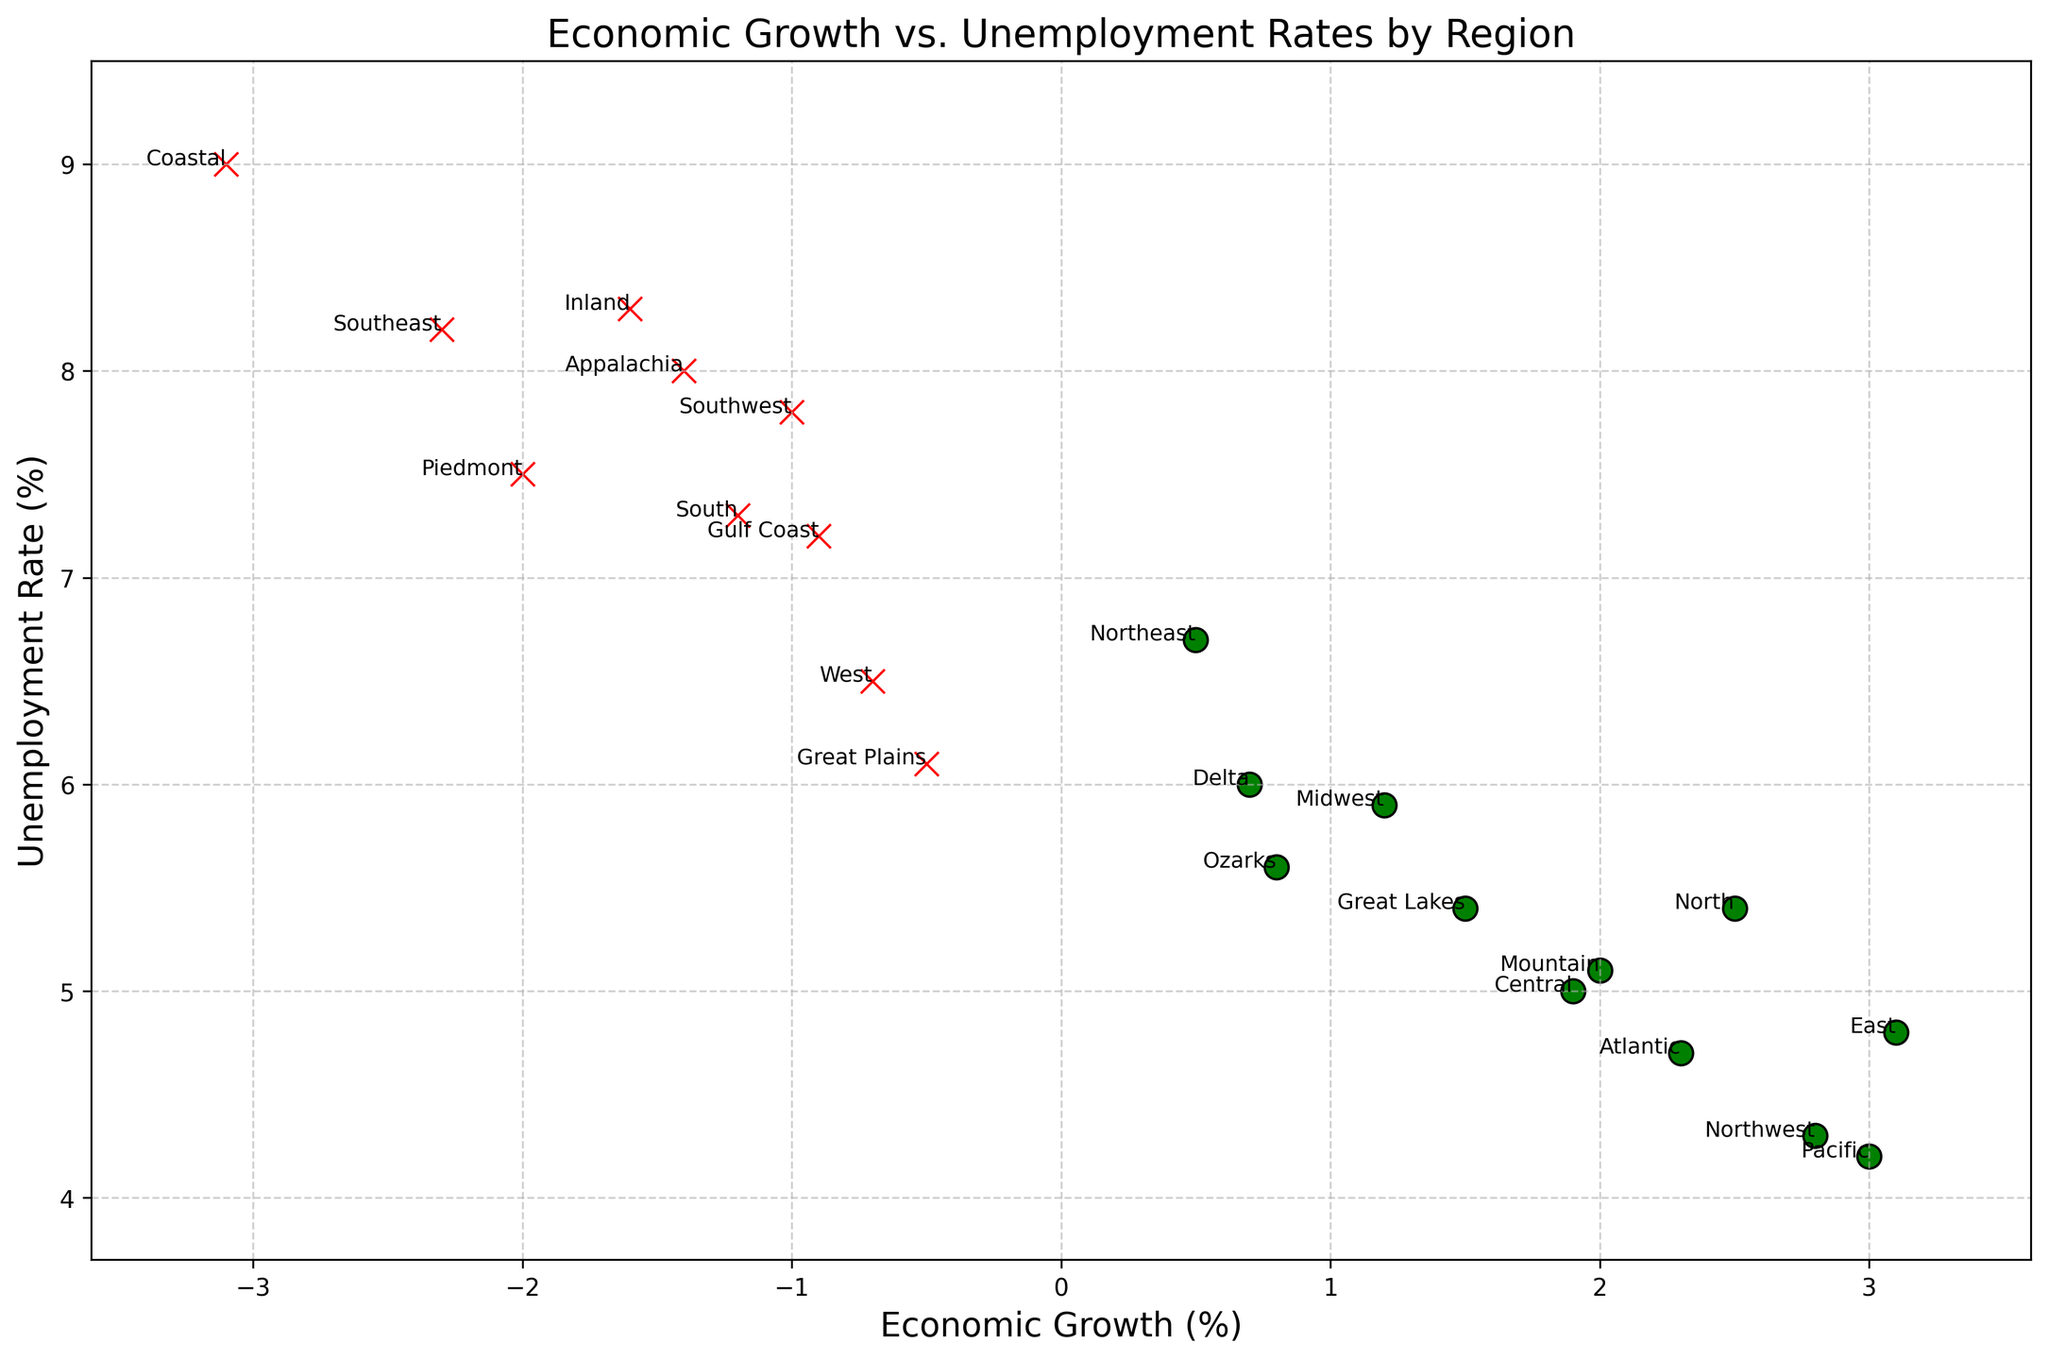Which region has the highest unemployment rate? To find the region with the highest unemployment rate, look for the point highest on the vertical scale. Coastal is at the topmost position.
Answer: Coastal Which region has the lowest rate of economic growth? Look for the point farthest to the left on the horizontal scale. Coastal is the farthest on the left.
Answer: Coastal How many regions experienced negative economic growth? Count the number of red "x" markers on the plot, which represent negative economic growth. There are eight such markers.
Answer: 8 Which regions have both positive economic growth and an unemployment rate below 5%? Look for green "o" markers below the 5% unemployment rate line. Northwest, Pacific, East, and Atlantic meet this criterion.
Answer: Northwest, Pacific, East, Atlantic What is the average unemployment rate of regions with negative economic growth? Calculate the average unemployment rate by adding the unemployment rates of all regions with red "x" markers and dividing by the number of such regions. Negative growth regions and their rates are Gulf Coast (7.2), Piedmont (7.5), Southwest (7.8), Appalachia (8.0), Southeast (8.2), Inland (8.3), Coastal (9.0), Delta (6.0), Ozarks (5.6), Great Plains (6.1), South (7.3), and West (6.5). The sum is 88.5, and with 12 regions, the average is 88.5 / 12 = 7.375%.
Answer: 7.375% Which region has the closest value to zero for economic growth? Look for the point closest to vertical line passing through zero on the horizontal scale. Great Plains is closest.
Answer: Great Plains Compare the regions Atlantic and Pacific in terms of economic growth and unemployment rate. Locate Atlantic and Pacific on the plot. Atlantic (upward right), Economic Growth: 2.3%, Unemployment Rate: 4.7%. Pacific (upward right), Economic Growth: 3.0%, Unemployment Rate: 4.2%. Both regions have positive growth and low unemployment, but Pacific has higher growth and slightly lower unemployment.
Answer: Pacific has higher growth and lower unemployment What percentage of regions have an unemployment rate above 6%? Count the number of regions with unemployment rates above 6%. There are 10 such regions. With 21 total regions, the percentage is (10 / 21) * 100 ≈ 47.62%.
Answer: 47.62% Which regions have positive economic growth but higher than average unemployment rates (above 5.72%)? Calculate the average unemployment rate (total sum/number of regions: 120.12 / 21 ≈ 5.72%). Identify green "o" markers above the average line. North and Midwest meet this criterion.
Answer: North, Midwest 